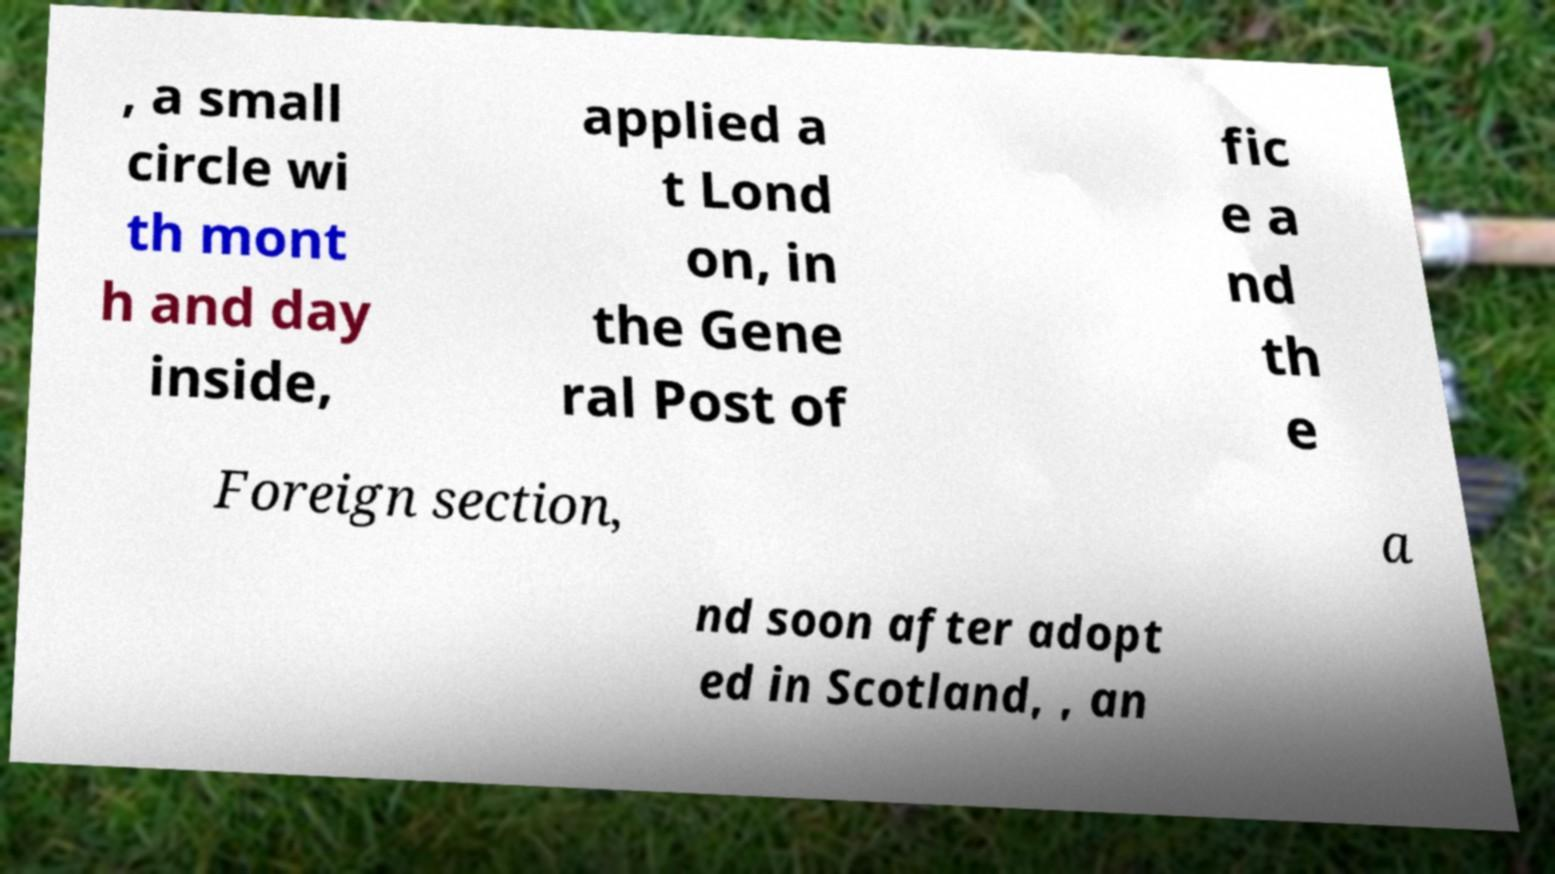What messages or text are displayed in this image? I need them in a readable, typed format. , a small circle wi th mont h and day inside, applied a t Lond on, in the Gene ral Post of fic e a nd th e Foreign section, a nd soon after adopt ed in Scotland, , an 